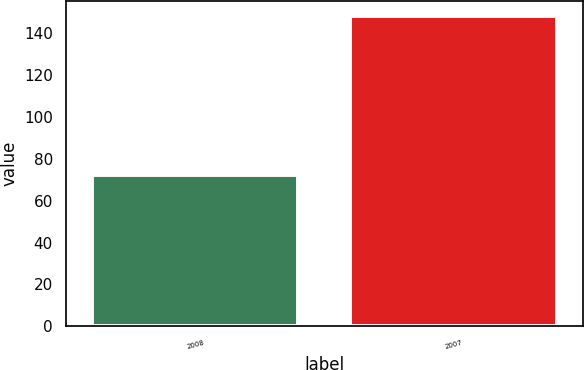Convert chart. <chart><loc_0><loc_0><loc_500><loc_500><bar_chart><fcel>2008<fcel>2007<nl><fcel>72<fcel>148<nl></chart> 